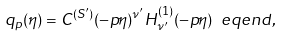Convert formula to latex. <formula><loc_0><loc_0><loc_500><loc_500>q _ { p } ( \eta ) = C ^ { ( S ^ { \prime } ) } ( - p \eta ) ^ { \nu ^ { \prime } } H _ { \nu ^ { \prime } } ^ { ( 1 ) } ( - p \eta ) \ e q e n d { , }</formula> 